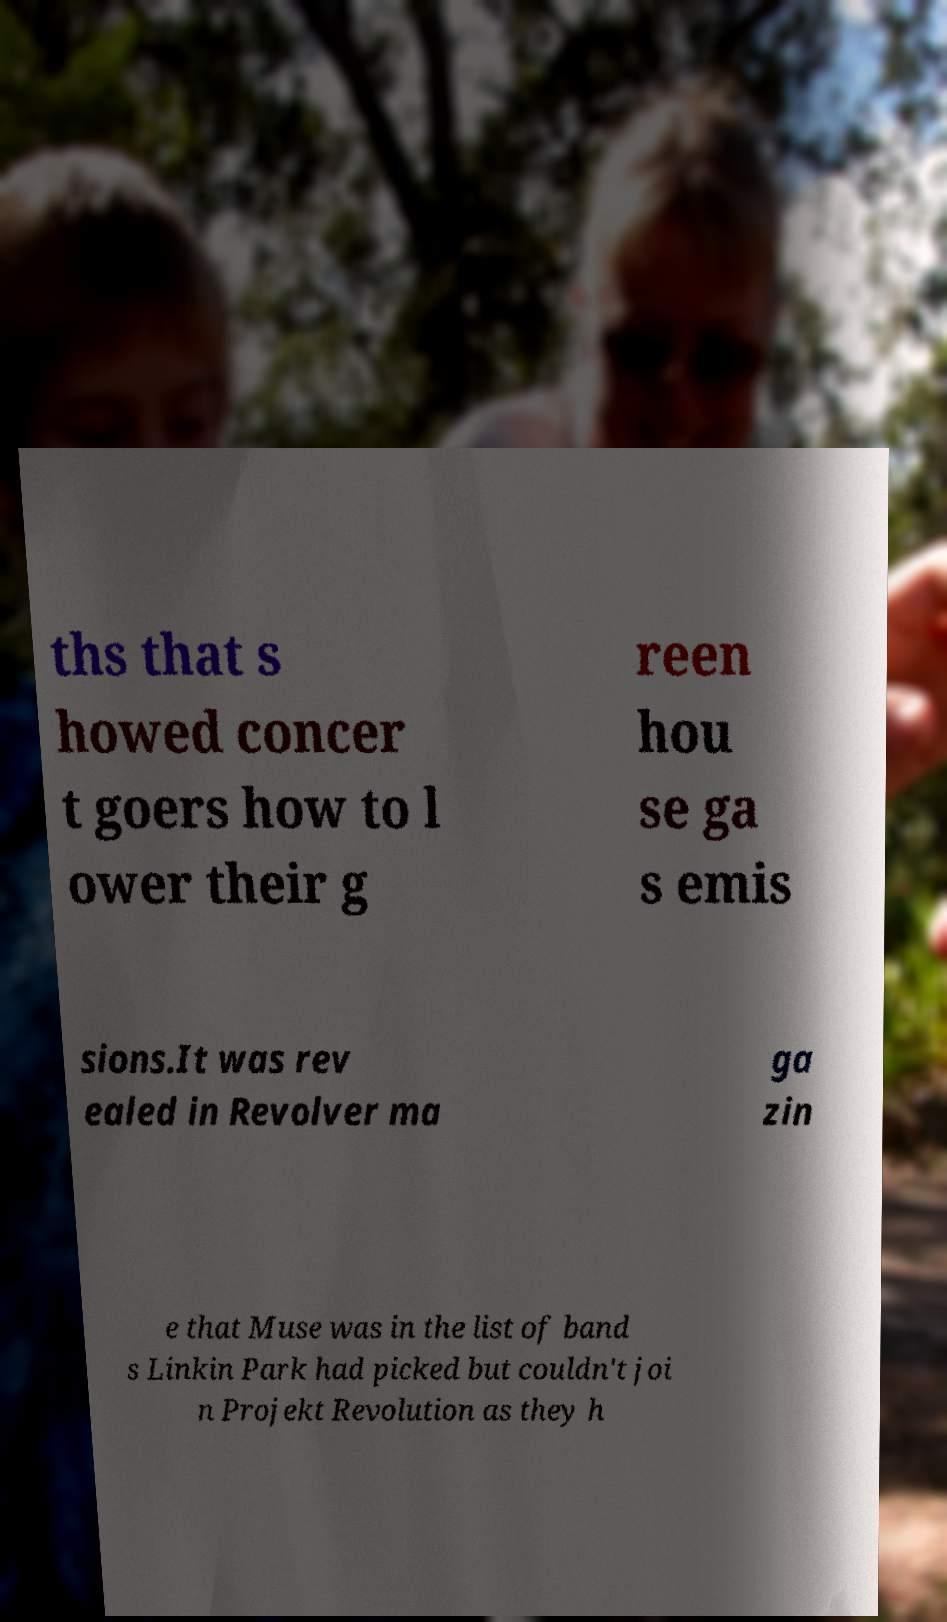For documentation purposes, I need the text within this image transcribed. Could you provide that? ths that s howed concer t goers how to l ower their g reen hou se ga s emis sions.It was rev ealed in Revolver ma ga zin e that Muse was in the list of band s Linkin Park had picked but couldn't joi n Projekt Revolution as they h 